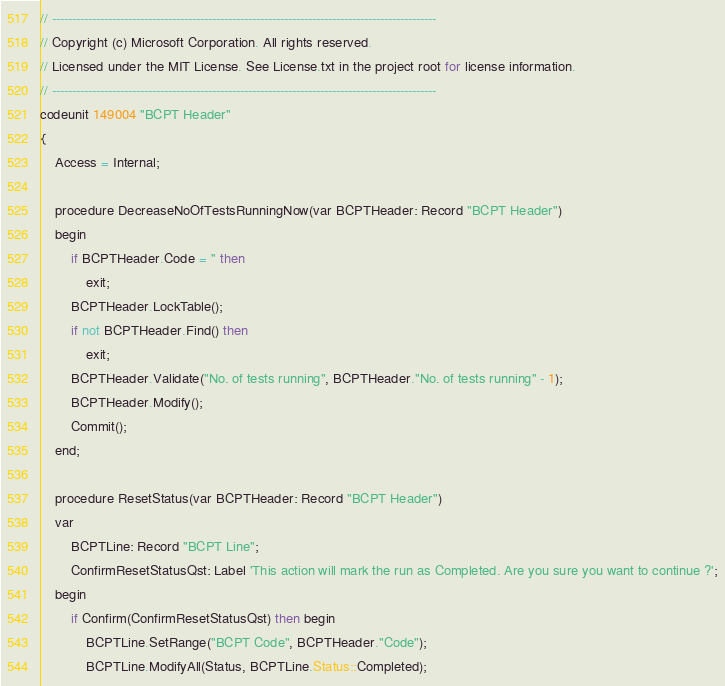Convert code to text. <code><loc_0><loc_0><loc_500><loc_500><_Perl_>// ------------------------------------------------------------------------------------------------
// Copyright (c) Microsoft Corporation. All rights reserved.
// Licensed under the MIT License. See License.txt in the project root for license information.
// ------------------------------------------------------------------------------------------------
codeunit 149004 "BCPT Header"
{
    Access = Internal;

    procedure DecreaseNoOfTestsRunningNow(var BCPTHeader: Record "BCPT Header")
    begin
        if BCPTHeader.Code = '' then
            exit;
        BCPTHeader.LockTable();
        if not BCPTHeader.Find() then
            exit;
        BCPTHeader.Validate("No. of tests running", BCPTHeader."No. of tests running" - 1);
        BCPTHeader.Modify();
        Commit();
    end;

    procedure ResetStatus(var BCPTHeader: Record "BCPT Header")
    var
        BCPTLine: Record "BCPT Line";
        ConfirmResetStatusQst: Label 'This action will mark the run as Completed. Are you sure you want to continue ?';
    begin
        if Confirm(ConfirmResetStatusQst) then begin
            BCPTLine.SetRange("BCPT Code", BCPTHeader."Code");
            BCPTLine.ModifyAll(Status, BCPTLine.Status::Completed);</code> 